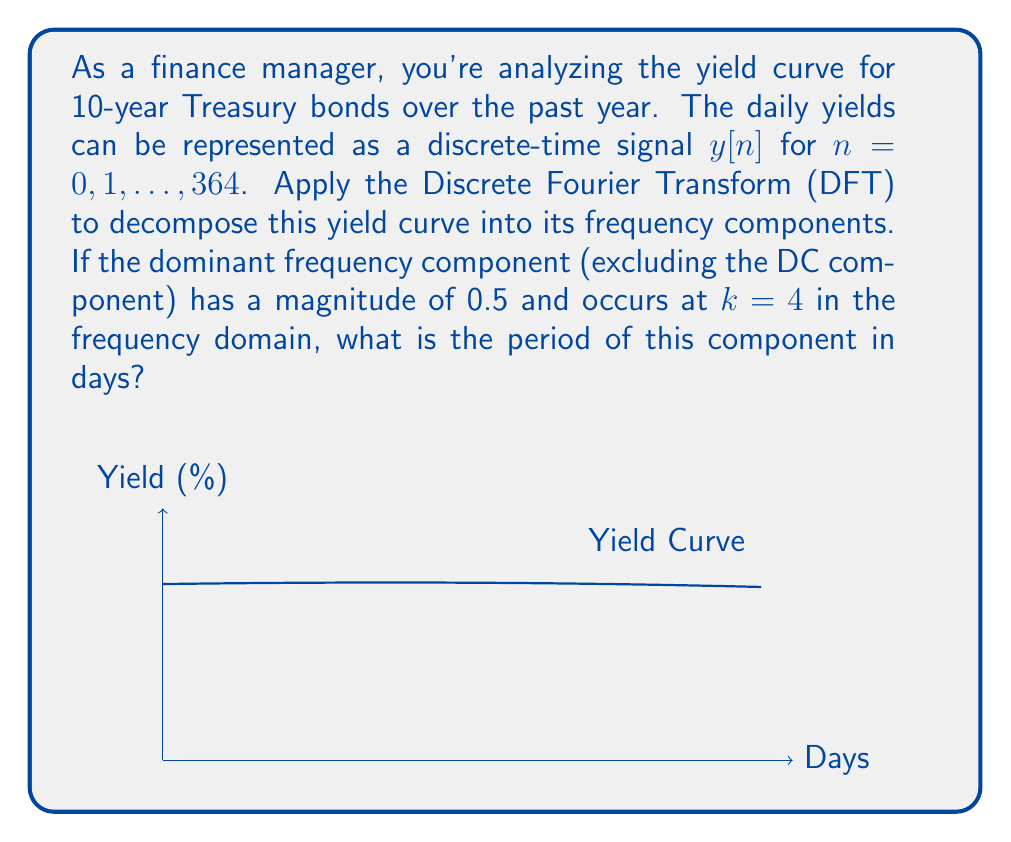Can you solve this math problem? To solve this problem, we need to understand the relationship between the DFT and the original signal:

1) The DFT of a discrete-time signal $y[n]$ of length $N$ is given by:

   $$Y[k] = \sum_{n=0}^{N-1} y[n] e^{-j2\pi kn/N}$$

   where $k = 0, 1, ..., N-1$ represents the frequency index.

2) In this case, $N = 365$ (number of days in a year).

3) The frequency corresponding to index $k$ is given by:

   $$f_k = \frac{k}{N} \cdot f_s$$

   where $f_s$ is the sampling frequency (1 sample per day in this case).

4) We're told that the dominant frequency component occurs at $k = 4$.

5) The period $T$ is the inverse of the frequency:

   $$T = \frac{1}{f_k} = \frac{N}{k} \text{ days}$$

6) Substituting the values:

   $$T = \frac{365}{4} = 91.25 \text{ days}$$

Therefore, the period of the dominant frequency component is 91.25 days.
Answer: 91.25 days 